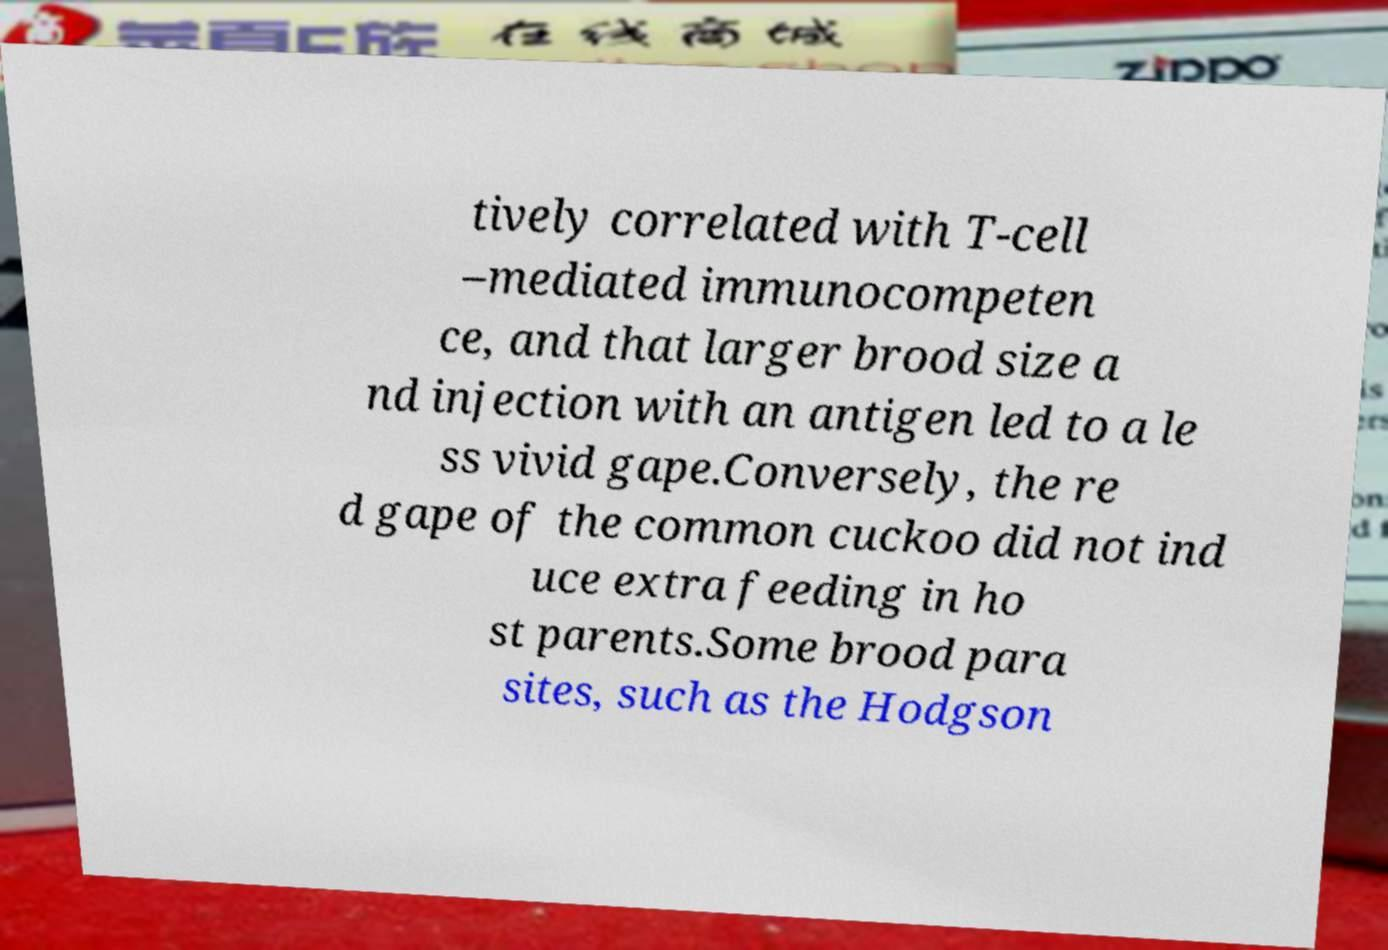What messages or text are displayed in this image? I need them in a readable, typed format. tively correlated with T-cell –mediated immunocompeten ce, and that larger brood size a nd injection with an antigen led to a le ss vivid gape.Conversely, the re d gape of the common cuckoo did not ind uce extra feeding in ho st parents.Some brood para sites, such as the Hodgson 